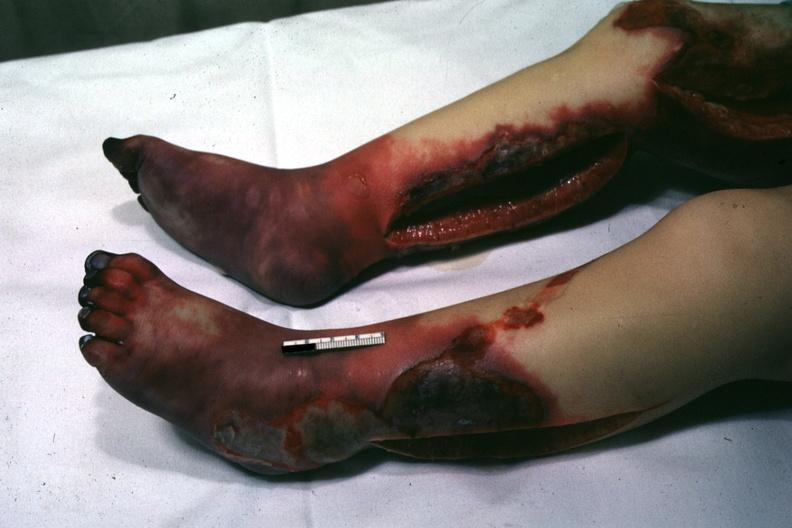what does this image show?
Answer the question using a single word or phrase. Horrible example of gangrene of feet and skin of legs with pseudomonas sepsis 